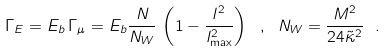Convert formula to latex. <formula><loc_0><loc_0><loc_500><loc_500>\Gamma _ { E } = E _ { b } \, \Gamma _ { \mu } = E _ { b } \frac { N } { N _ { W } } \, \left ( 1 - \frac { l ^ { 2 } } { l _ { \max } ^ { 2 } } \right ) \ , \ N _ { W } = \frac { M ^ { 2 } } { 2 4 \tilde { \kappa } ^ { 2 } } \ .</formula> 